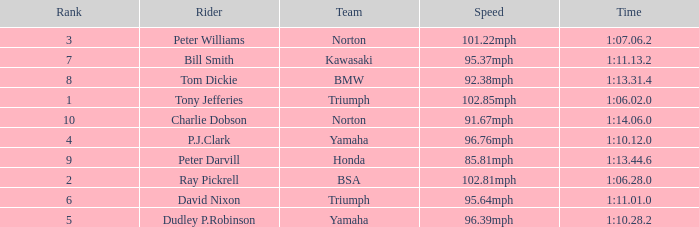Parse the full table. {'header': ['Rank', 'Rider', 'Team', 'Speed', 'Time'], 'rows': [['3', 'Peter Williams', 'Norton', '101.22mph', '1:07.06.2'], ['7', 'Bill Smith', 'Kawasaki', '95.37mph', '1:11.13.2'], ['8', 'Tom Dickie', 'BMW', '92.38mph', '1:13.31.4'], ['1', 'Tony Jefferies', 'Triumph', '102.85mph', '1:06.02.0'], ['10', 'Charlie Dobson', 'Norton', '91.67mph', '1:14.06.0'], ['4', 'P.J.Clark', 'Yamaha', '96.76mph', '1:10.12.0'], ['9', 'Peter Darvill', 'Honda', '85.81mph', '1:13.44.6'], ['2', 'Ray Pickrell', 'BSA', '102.81mph', '1:06.28.0'], ['6', 'David Nixon', 'Triumph', '95.64mph', '1:11.01.0'], ['5', 'Dudley P.Robinson', 'Yamaha', '96.39mph', '1:10.28.2']]} At 96.76mph speed, what is the Time? 1:10.12.0. 